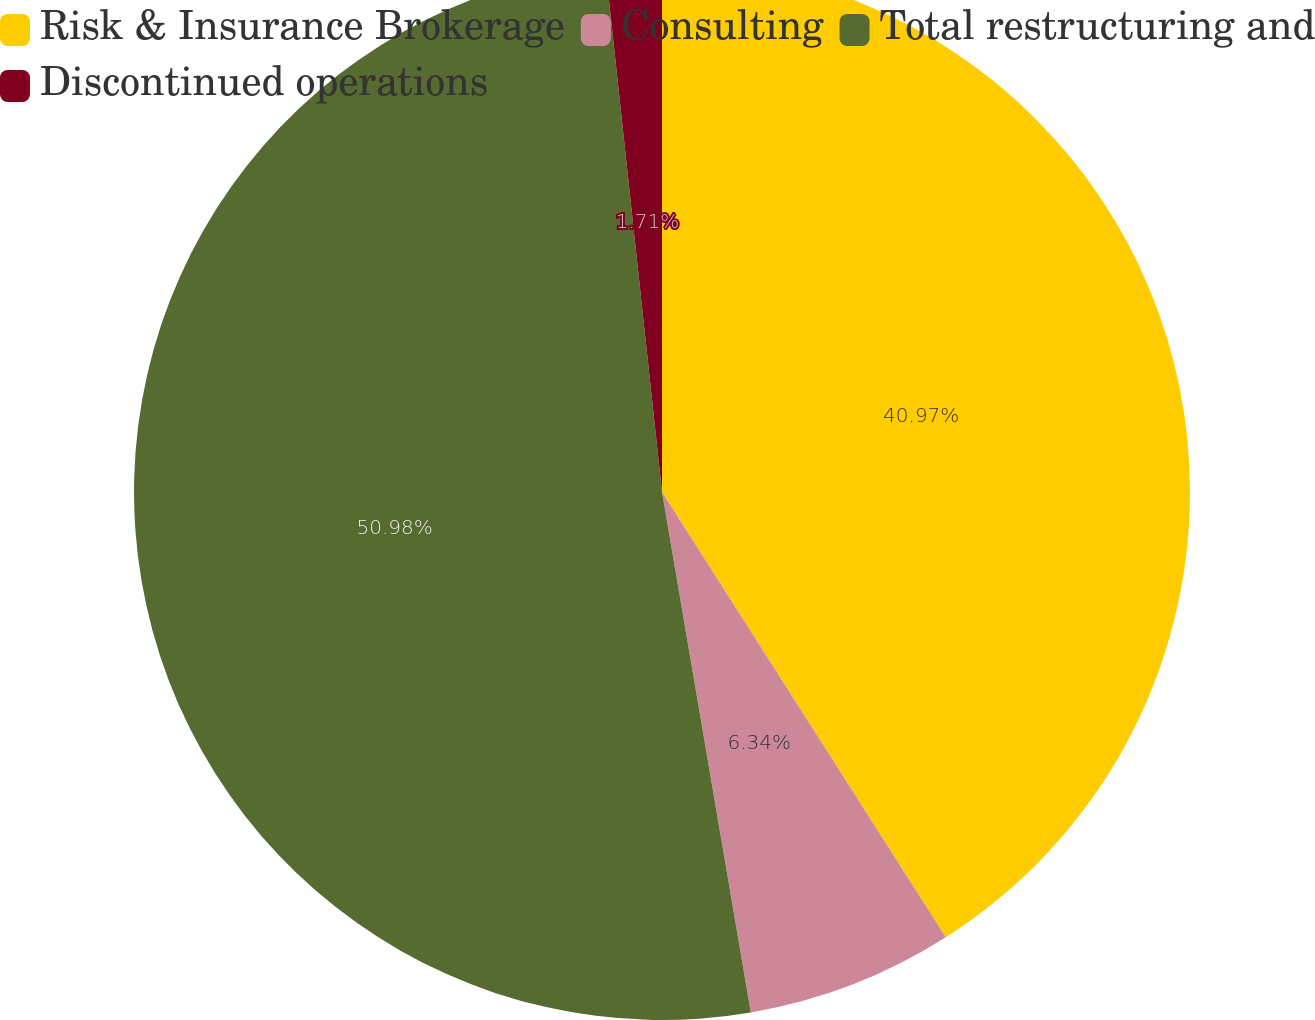Convert chart to OTSL. <chart><loc_0><loc_0><loc_500><loc_500><pie_chart><fcel>Risk & Insurance Brokerage<fcel>Consulting<fcel>Total restructuring and<fcel>Discontinued operations<nl><fcel>40.97%<fcel>6.34%<fcel>50.98%<fcel>1.71%<nl></chart> 